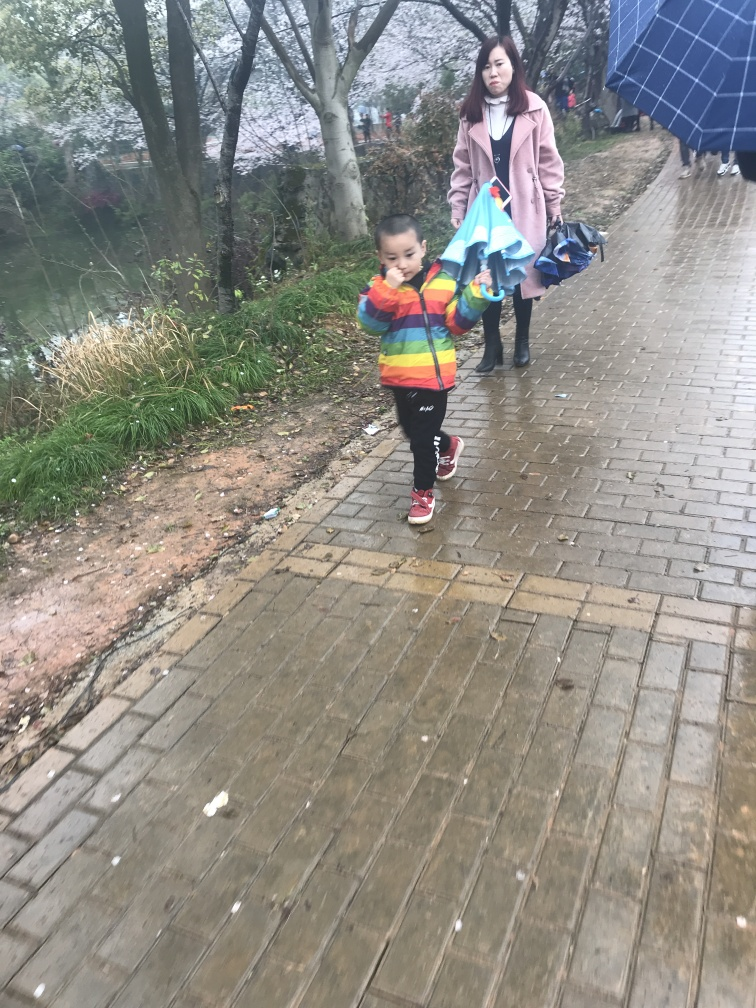How would you describe the mood or atmosphere of this image? The image has a quiet and still atmosphere, heightened by the absence of other people and the serene, natural setting. The mood could be described as tranquil, with a touch of solitude as the two figures seem to be in their own world. 